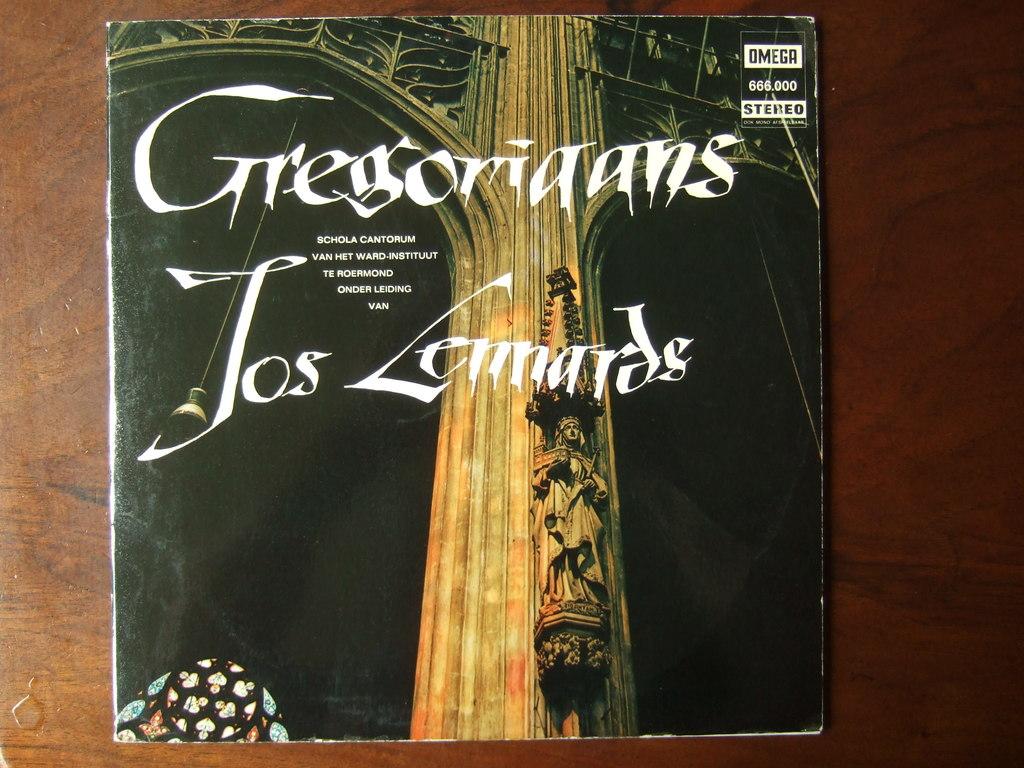Is this font is to read for you?
Provide a succinct answer. Unanswerable. What number can be seen in the top right?
Offer a terse response. 666.000. 